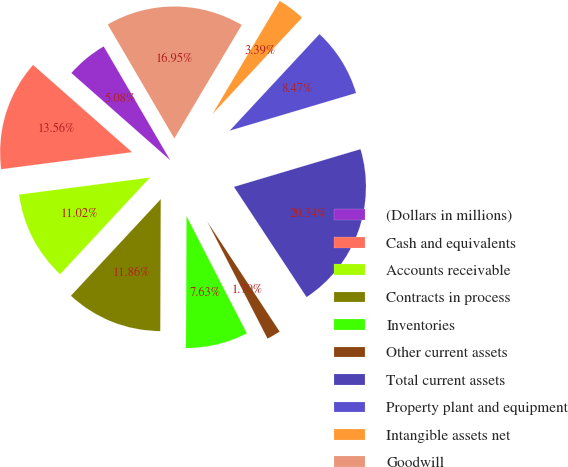Convert chart to OTSL. <chart><loc_0><loc_0><loc_500><loc_500><pie_chart><fcel>(Dollars in millions)<fcel>Cash and equivalents<fcel>Accounts receivable<fcel>Contracts in process<fcel>Inventories<fcel>Other current assets<fcel>Total current assets<fcel>Property plant and equipment<fcel>Intangible assets net<fcel>Goodwill<nl><fcel>5.08%<fcel>13.56%<fcel>11.02%<fcel>11.86%<fcel>7.63%<fcel>1.7%<fcel>20.34%<fcel>8.47%<fcel>3.39%<fcel>16.95%<nl></chart> 